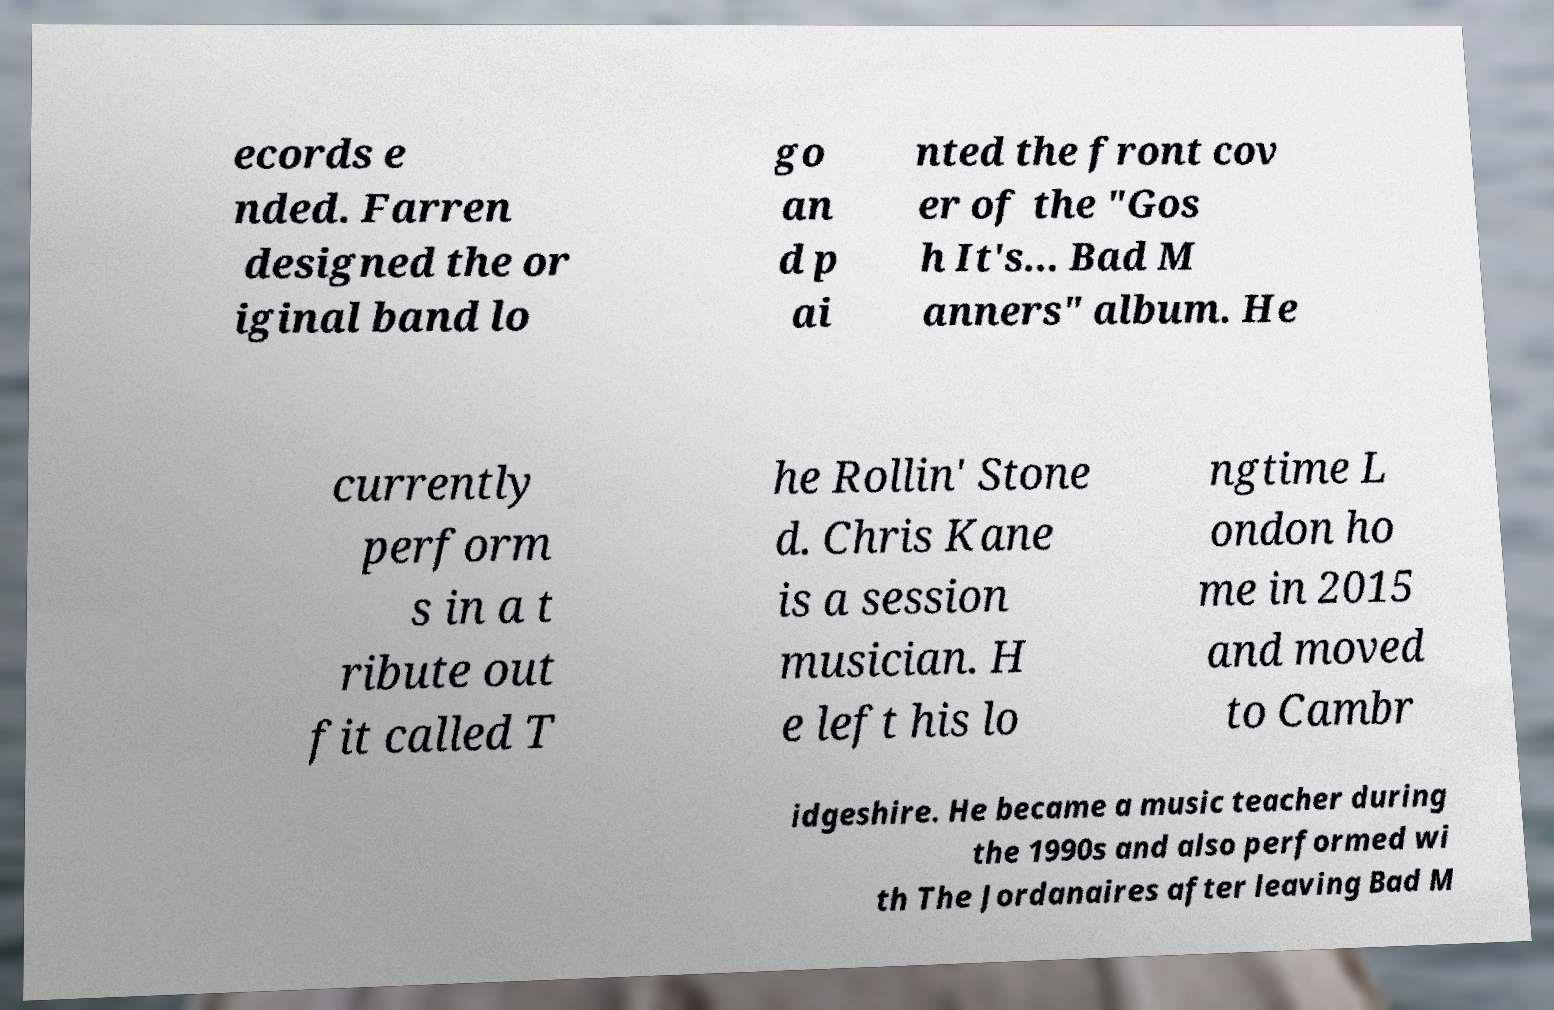Please identify and transcribe the text found in this image. ecords e nded. Farren designed the or iginal band lo go an d p ai nted the front cov er of the "Gos h It's... Bad M anners" album. He currently perform s in a t ribute out fit called T he Rollin' Stone d. Chris Kane is a session musician. H e left his lo ngtime L ondon ho me in 2015 and moved to Cambr idgeshire. He became a music teacher during the 1990s and also performed wi th The Jordanaires after leaving Bad M 